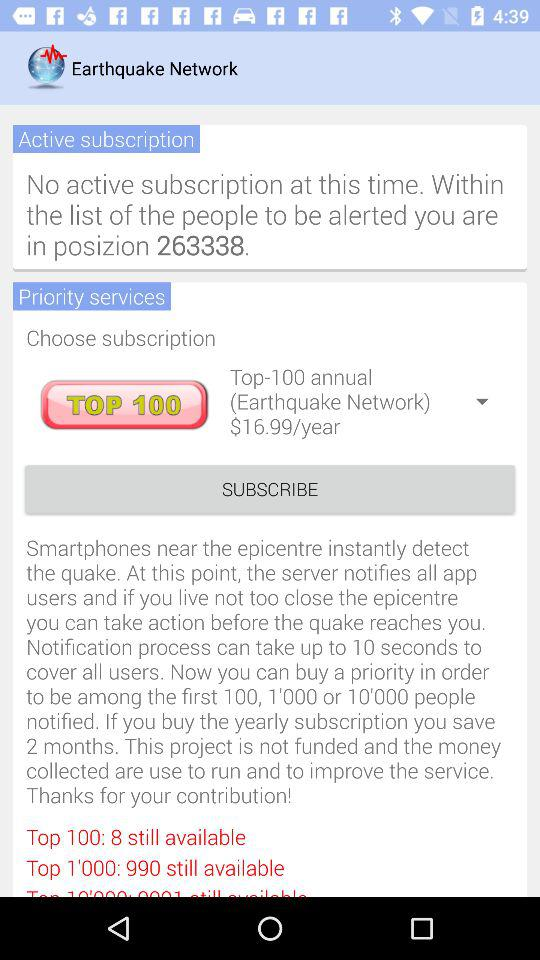Is there any active subscription? There is no active subscription. 